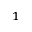Convert formula to latex. <formula><loc_0><loc_0><loc_500><loc_500>^ { 1 }</formula> 